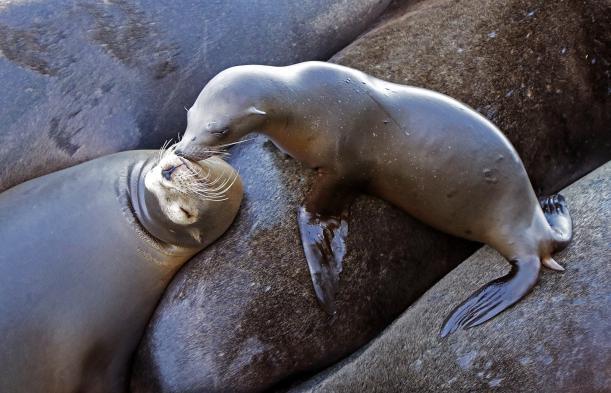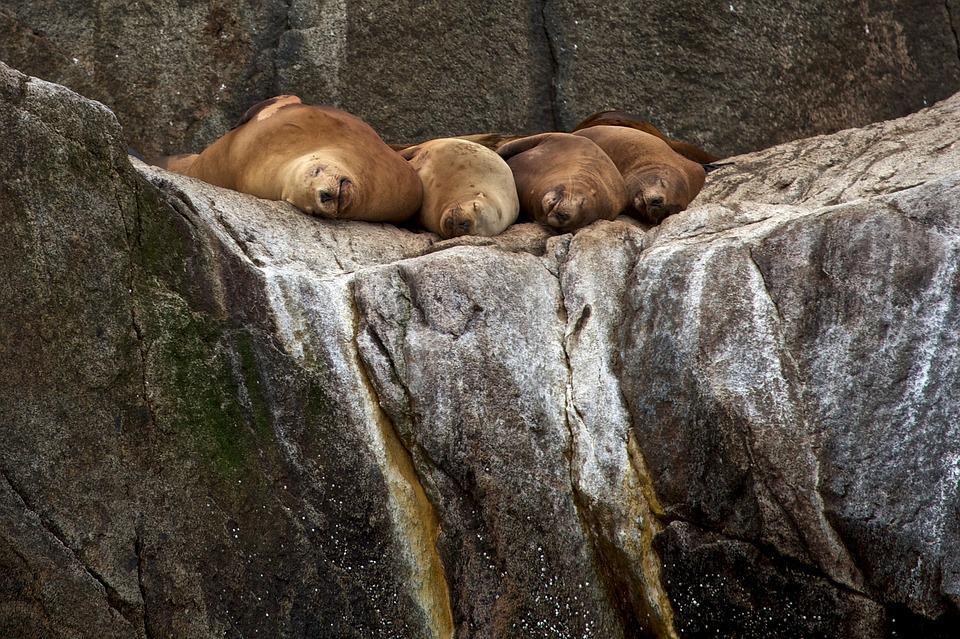The first image is the image on the left, the second image is the image on the right. Examine the images to the left and right. Is the description "Exactly four seal heads are visible in one of the images." accurate? Answer yes or no. Yes. The first image is the image on the left, the second image is the image on the right. Analyze the images presented: Is the assertion "The right image contains no more than four seals." valid? Answer yes or no. Yes. 